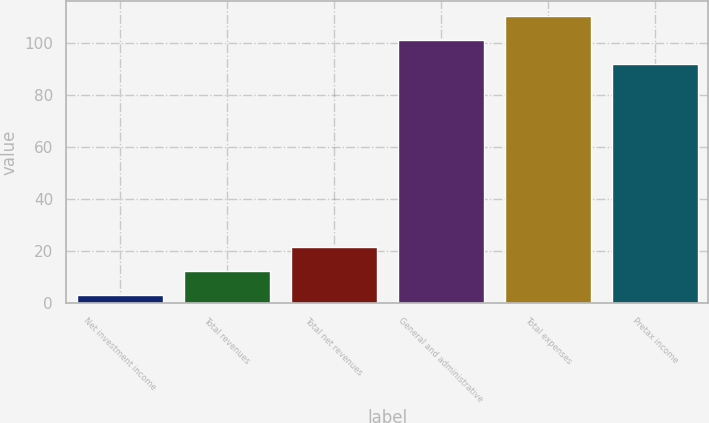<chart> <loc_0><loc_0><loc_500><loc_500><bar_chart><fcel>Net investment income<fcel>Total revenues<fcel>Total net revenues<fcel>General and administrative<fcel>Total expenses<fcel>Pretax income<nl><fcel>3<fcel>12.2<fcel>21.4<fcel>101.2<fcel>110.4<fcel>92<nl></chart> 